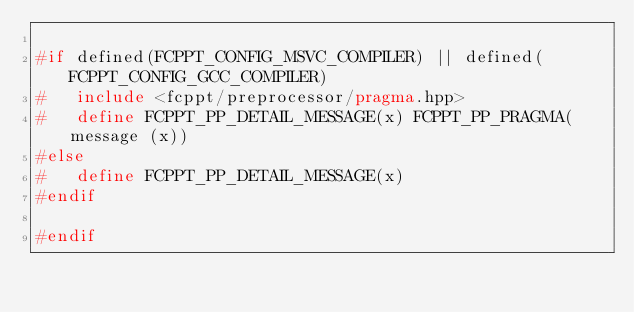Convert code to text. <code><loc_0><loc_0><loc_500><loc_500><_C++_>
#if defined(FCPPT_CONFIG_MSVC_COMPILER) || defined(FCPPT_CONFIG_GCC_COMPILER)
#	include <fcppt/preprocessor/pragma.hpp>
#	define FCPPT_PP_DETAIL_MESSAGE(x) FCPPT_PP_PRAGMA(message (x))
#else
#	define FCPPT_PP_DETAIL_MESSAGE(x)
#endif

#endif
</code> 